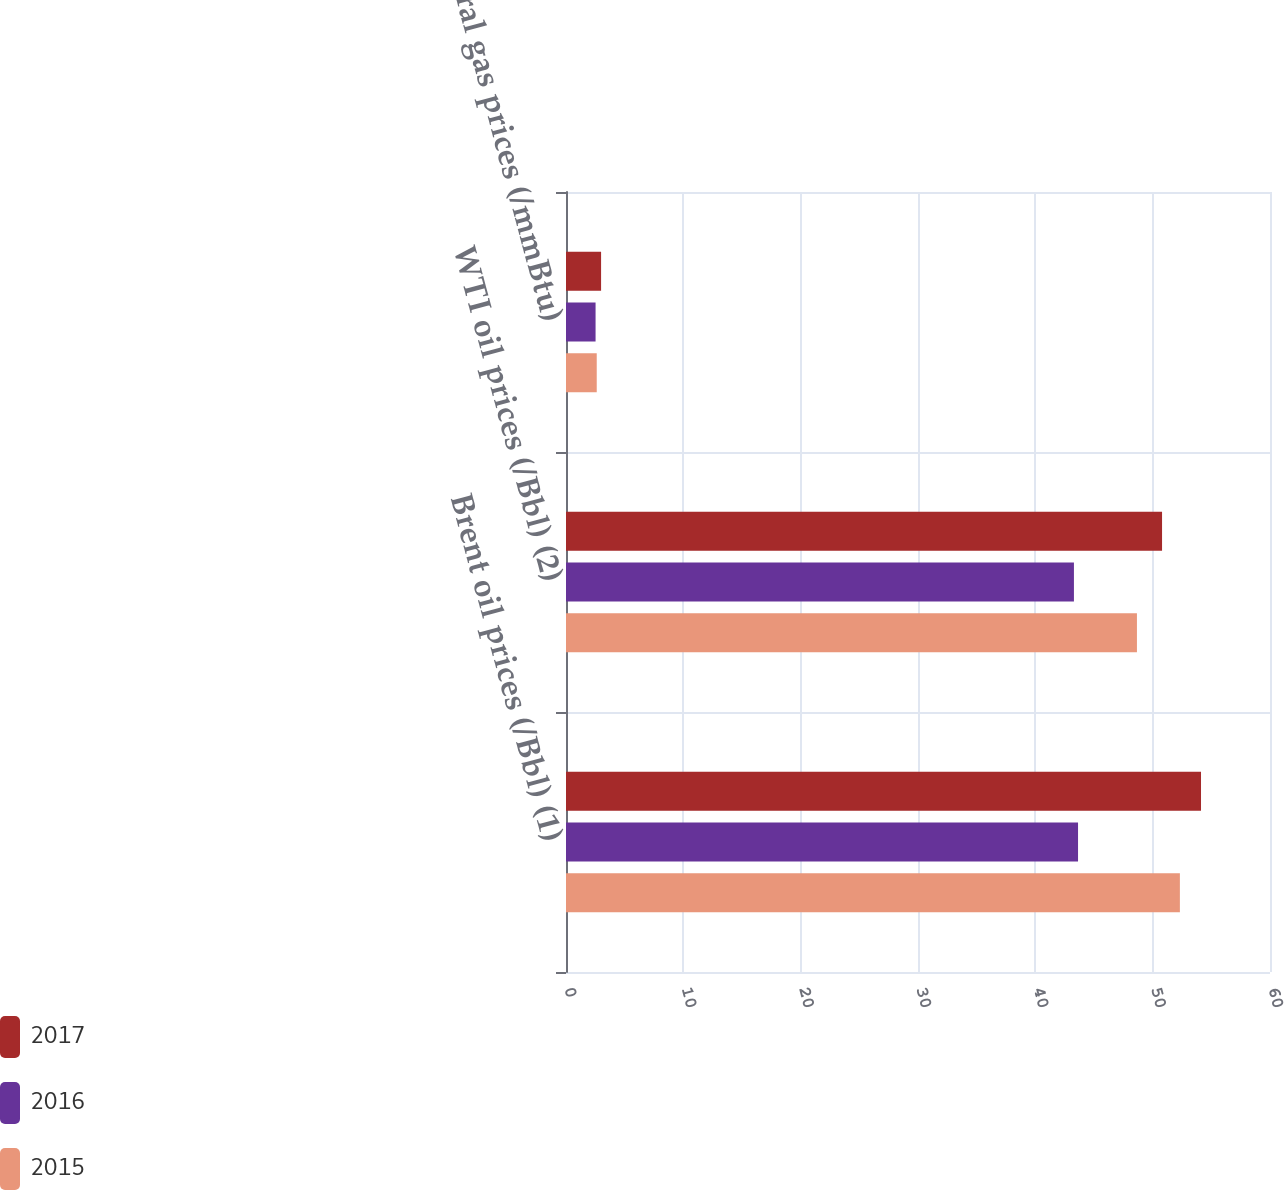<chart> <loc_0><loc_0><loc_500><loc_500><stacked_bar_chart><ecel><fcel>Brent oil prices (/Bbl) (1)<fcel>WTI oil prices (/Bbl) (2)<fcel>Natural gas prices (/mmBtu)<nl><fcel>2017<fcel>54.12<fcel>50.8<fcel>2.99<nl><fcel>2016<fcel>43.64<fcel>43.29<fcel>2.52<nl><fcel>2015<fcel>52.32<fcel>48.66<fcel>2.62<nl></chart> 